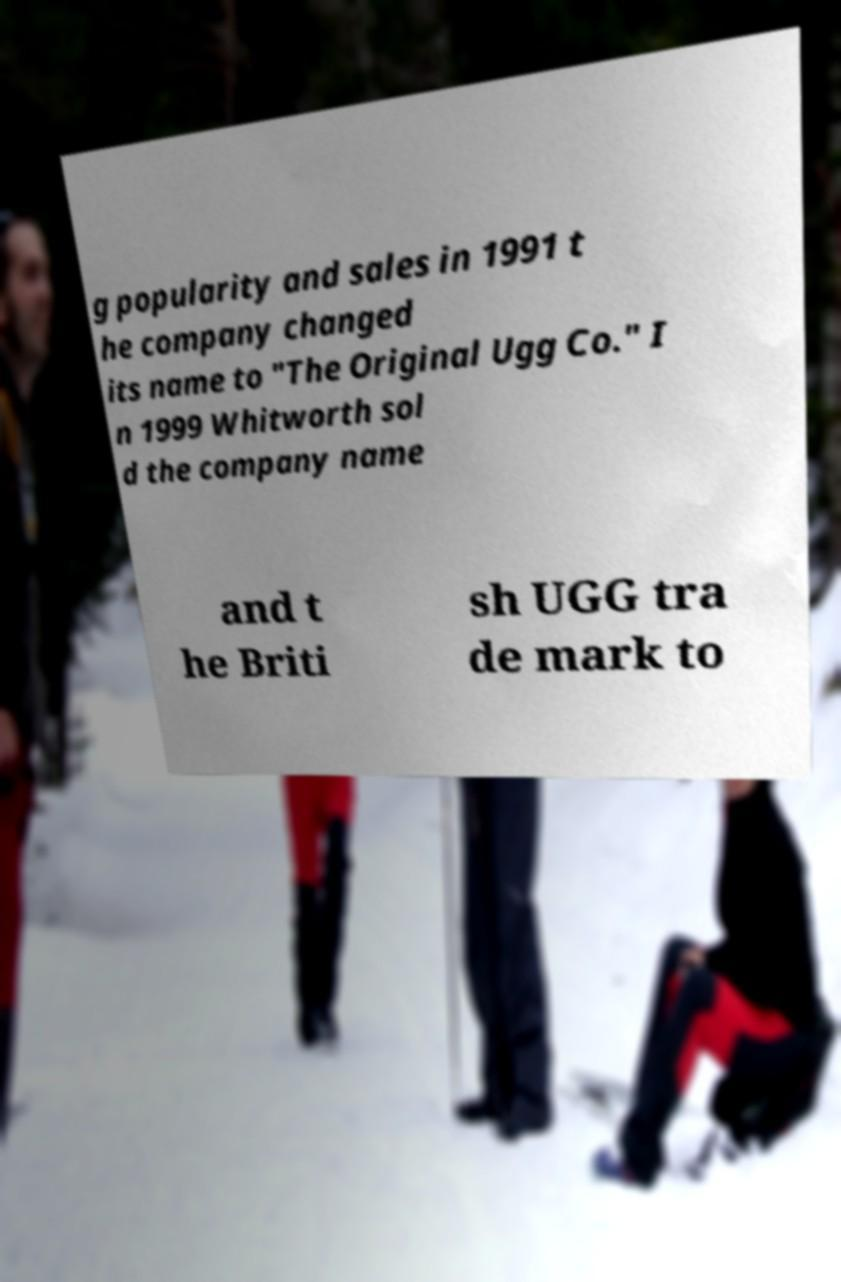What messages or text are displayed in this image? I need them in a readable, typed format. g popularity and sales in 1991 t he company changed its name to "The Original Ugg Co." I n 1999 Whitworth sol d the company name and t he Briti sh UGG tra de mark to 